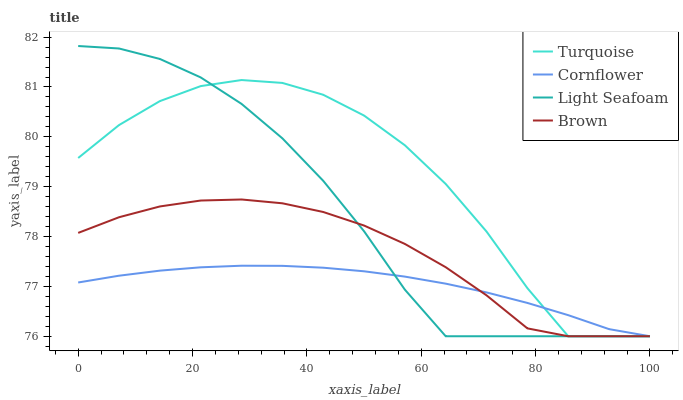Does Cornflower have the minimum area under the curve?
Answer yes or no. Yes. Does Turquoise have the maximum area under the curve?
Answer yes or no. Yes. Does Light Seafoam have the minimum area under the curve?
Answer yes or no. No. Does Light Seafoam have the maximum area under the curve?
Answer yes or no. No. Is Cornflower the smoothest?
Answer yes or no. Yes. Is Turquoise the roughest?
Answer yes or no. Yes. Is Light Seafoam the smoothest?
Answer yes or no. No. Is Light Seafoam the roughest?
Answer yes or no. No. Does Cornflower have the lowest value?
Answer yes or no. Yes. Does Light Seafoam have the highest value?
Answer yes or no. Yes. Does Turquoise have the highest value?
Answer yes or no. No. Does Cornflower intersect Brown?
Answer yes or no. Yes. Is Cornflower less than Brown?
Answer yes or no. No. Is Cornflower greater than Brown?
Answer yes or no. No. 